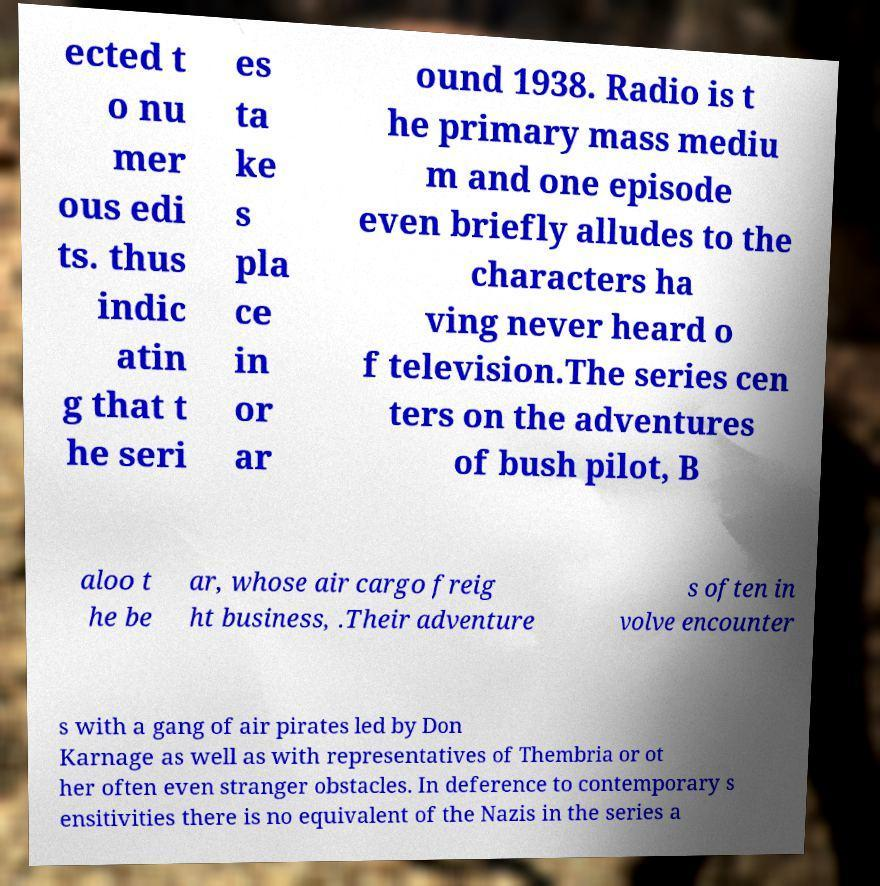Can you accurately transcribe the text from the provided image for me? ected t o nu mer ous edi ts. thus indic atin g that t he seri es ta ke s pla ce in or ar ound 1938. Radio is t he primary mass mediu m and one episode even briefly alludes to the characters ha ving never heard o f television.The series cen ters on the adventures of bush pilot, B aloo t he be ar, whose air cargo freig ht business, .Their adventure s often in volve encounter s with a gang of air pirates led by Don Karnage as well as with representatives of Thembria or ot her often even stranger obstacles. In deference to contemporary s ensitivities there is no equivalent of the Nazis in the series a 